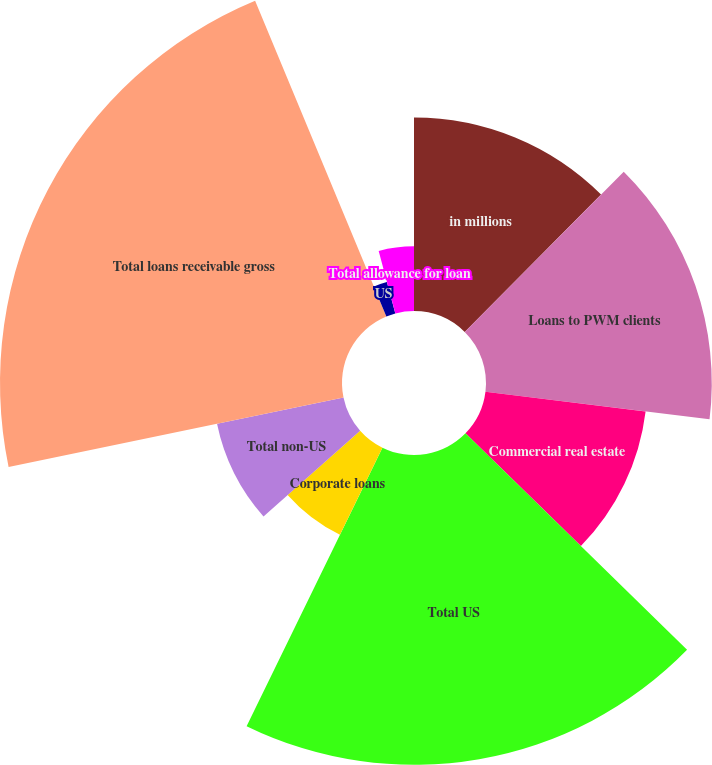Convert chart to OTSL. <chart><loc_0><loc_0><loc_500><loc_500><pie_chart><fcel>in millions<fcel>Loans to PWM clients<fcel>Commercial real estate<fcel>Total US<fcel>Corporate loans<fcel>Total non-US<fcel>Total loans receivable gross<fcel>US<fcel>Non-US<fcel>Total allowance for loan<nl><fcel>12.44%<fcel>14.51%<fcel>10.37%<fcel>19.91%<fcel>6.23%<fcel>8.3%<fcel>21.98%<fcel>2.09%<fcel>0.02%<fcel>4.16%<nl></chart> 